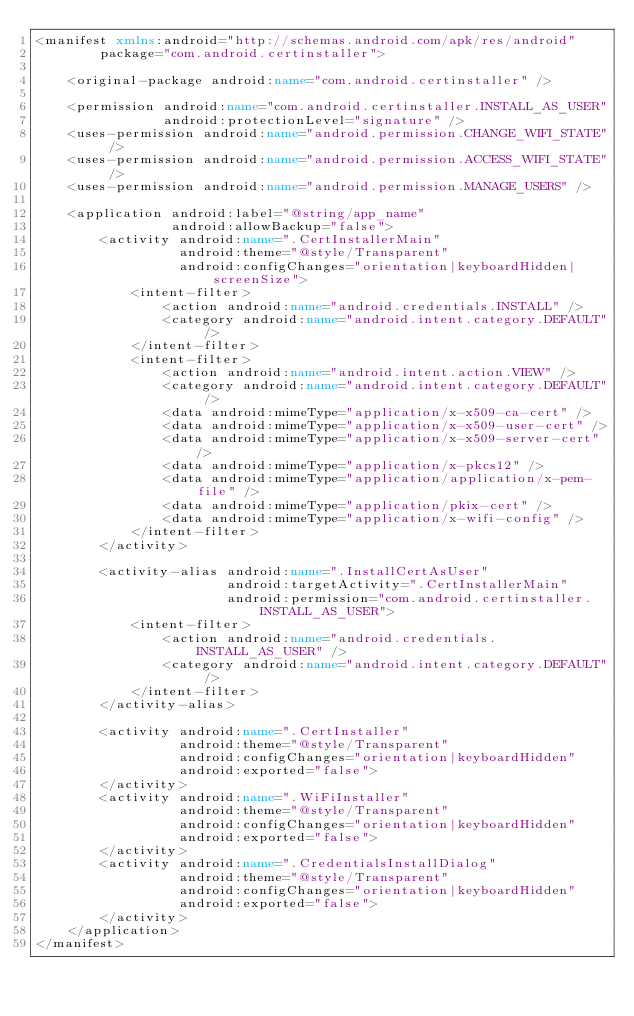<code> <loc_0><loc_0><loc_500><loc_500><_XML_><manifest xmlns:android="http://schemas.android.com/apk/res/android"
        package="com.android.certinstaller">

    <original-package android:name="com.android.certinstaller" />

    <permission android:name="com.android.certinstaller.INSTALL_AS_USER"
                android:protectionLevel="signature" />
    <uses-permission android:name="android.permission.CHANGE_WIFI_STATE" />
    <uses-permission android:name="android.permission.ACCESS_WIFI_STATE" />
    <uses-permission android:name="android.permission.MANAGE_USERS" />

    <application android:label="@string/app_name"
                 android:allowBackup="false">
        <activity android:name=".CertInstallerMain"
                  android:theme="@style/Transparent"
                  android:configChanges="orientation|keyboardHidden|screenSize">
            <intent-filter>
                <action android:name="android.credentials.INSTALL" />
                <category android:name="android.intent.category.DEFAULT" />
            </intent-filter>
            <intent-filter>
                <action android:name="android.intent.action.VIEW" />
                <category android:name="android.intent.category.DEFAULT" />
                <data android:mimeType="application/x-x509-ca-cert" />
                <data android:mimeType="application/x-x509-user-cert" />
                <data android:mimeType="application/x-x509-server-cert" />
                <data android:mimeType="application/x-pkcs12" />
                <data android:mimeType="application/application/x-pem-file" />
                <data android:mimeType="application/pkix-cert" />
                <data android:mimeType="application/x-wifi-config" />
            </intent-filter>
        </activity>

        <activity-alias android:name=".InstallCertAsUser"
                        android:targetActivity=".CertInstallerMain"
                        android:permission="com.android.certinstaller.INSTALL_AS_USER">
            <intent-filter>
                <action android:name="android.credentials.INSTALL_AS_USER" />
                <category android:name="android.intent.category.DEFAULT" />
            </intent-filter>
        </activity-alias>

        <activity android:name=".CertInstaller"
                  android:theme="@style/Transparent"
                  android:configChanges="orientation|keyboardHidden"
                  android:exported="false">
        </activity>
        <activity android:name=".WiFiInstaller"
                  android:theme="@style/Transparent"
                  android:configChanges="orientation|keyboardHidden"
                  android:exported="false">
        </activity>
        <activity android:name=".CredentialsInstallDialog"
                  android:theme="@style/Transparent"
                  android:configChanges="orientation|keyboardHidden"
                  android:exported="false">
        </activity>
    </application>
</manifest>
</code> 